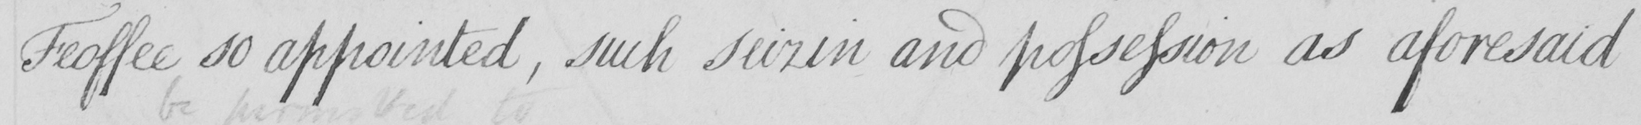Can you tell me what this handwritten text says? Feoffee so appointed , such seizin and possession as aforesaid 